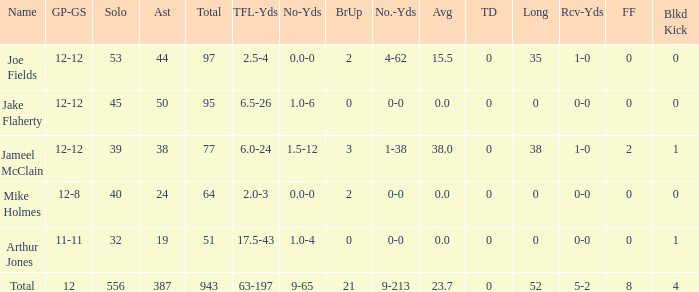How many tackle assists for the player who averages 23.7? 387.0. 